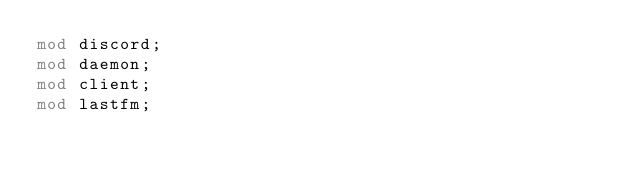Convert code to text. <code><loc_0><loc_0><loc_500><loc_500><_Rust_>mod discord;
mod daemon;
mod client;
mod lastfm;
</code> 